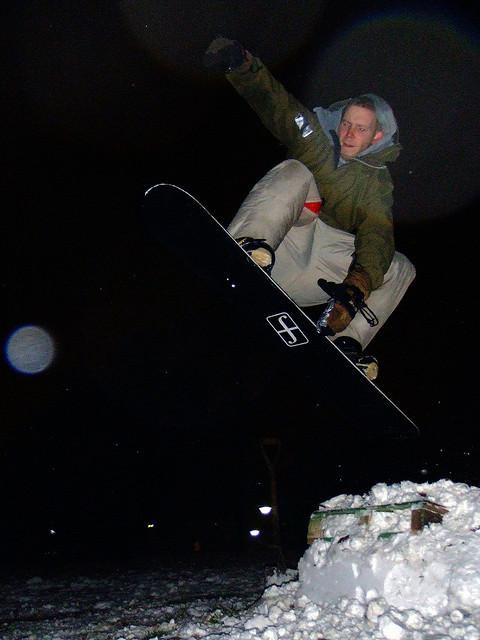Where is the man holding a snowboard?
Keep it brief. In air. What is the man riding?
Answer briefly. Snowboard. Will the snowboarder crash if he maintains this exact position?
Concise answer only. No. What sport is shown here?
Be succinct. Snowboarding. What is the man doing?
Give a very brief answer. Snowboarding. What color is the snowboard?
Concise answer only. Black. Is he flying?
Short answer required. Yes. What color of gloves do they have on?
Short answer required. Black. What is the man riding on?
Write a very short answer. Snowboard. What sport is depicted?
Write a very short answer. Snowboarding. Is there anyone else in the picture?
Keep it brief. No. What is the kid riding?
Concise answer only. Snowboard. Is this person's head covered by clothing or not?
Write a very short answer. Yes. What sport is being practiced in the scene?
Write a very short answer. Snowboarding. 